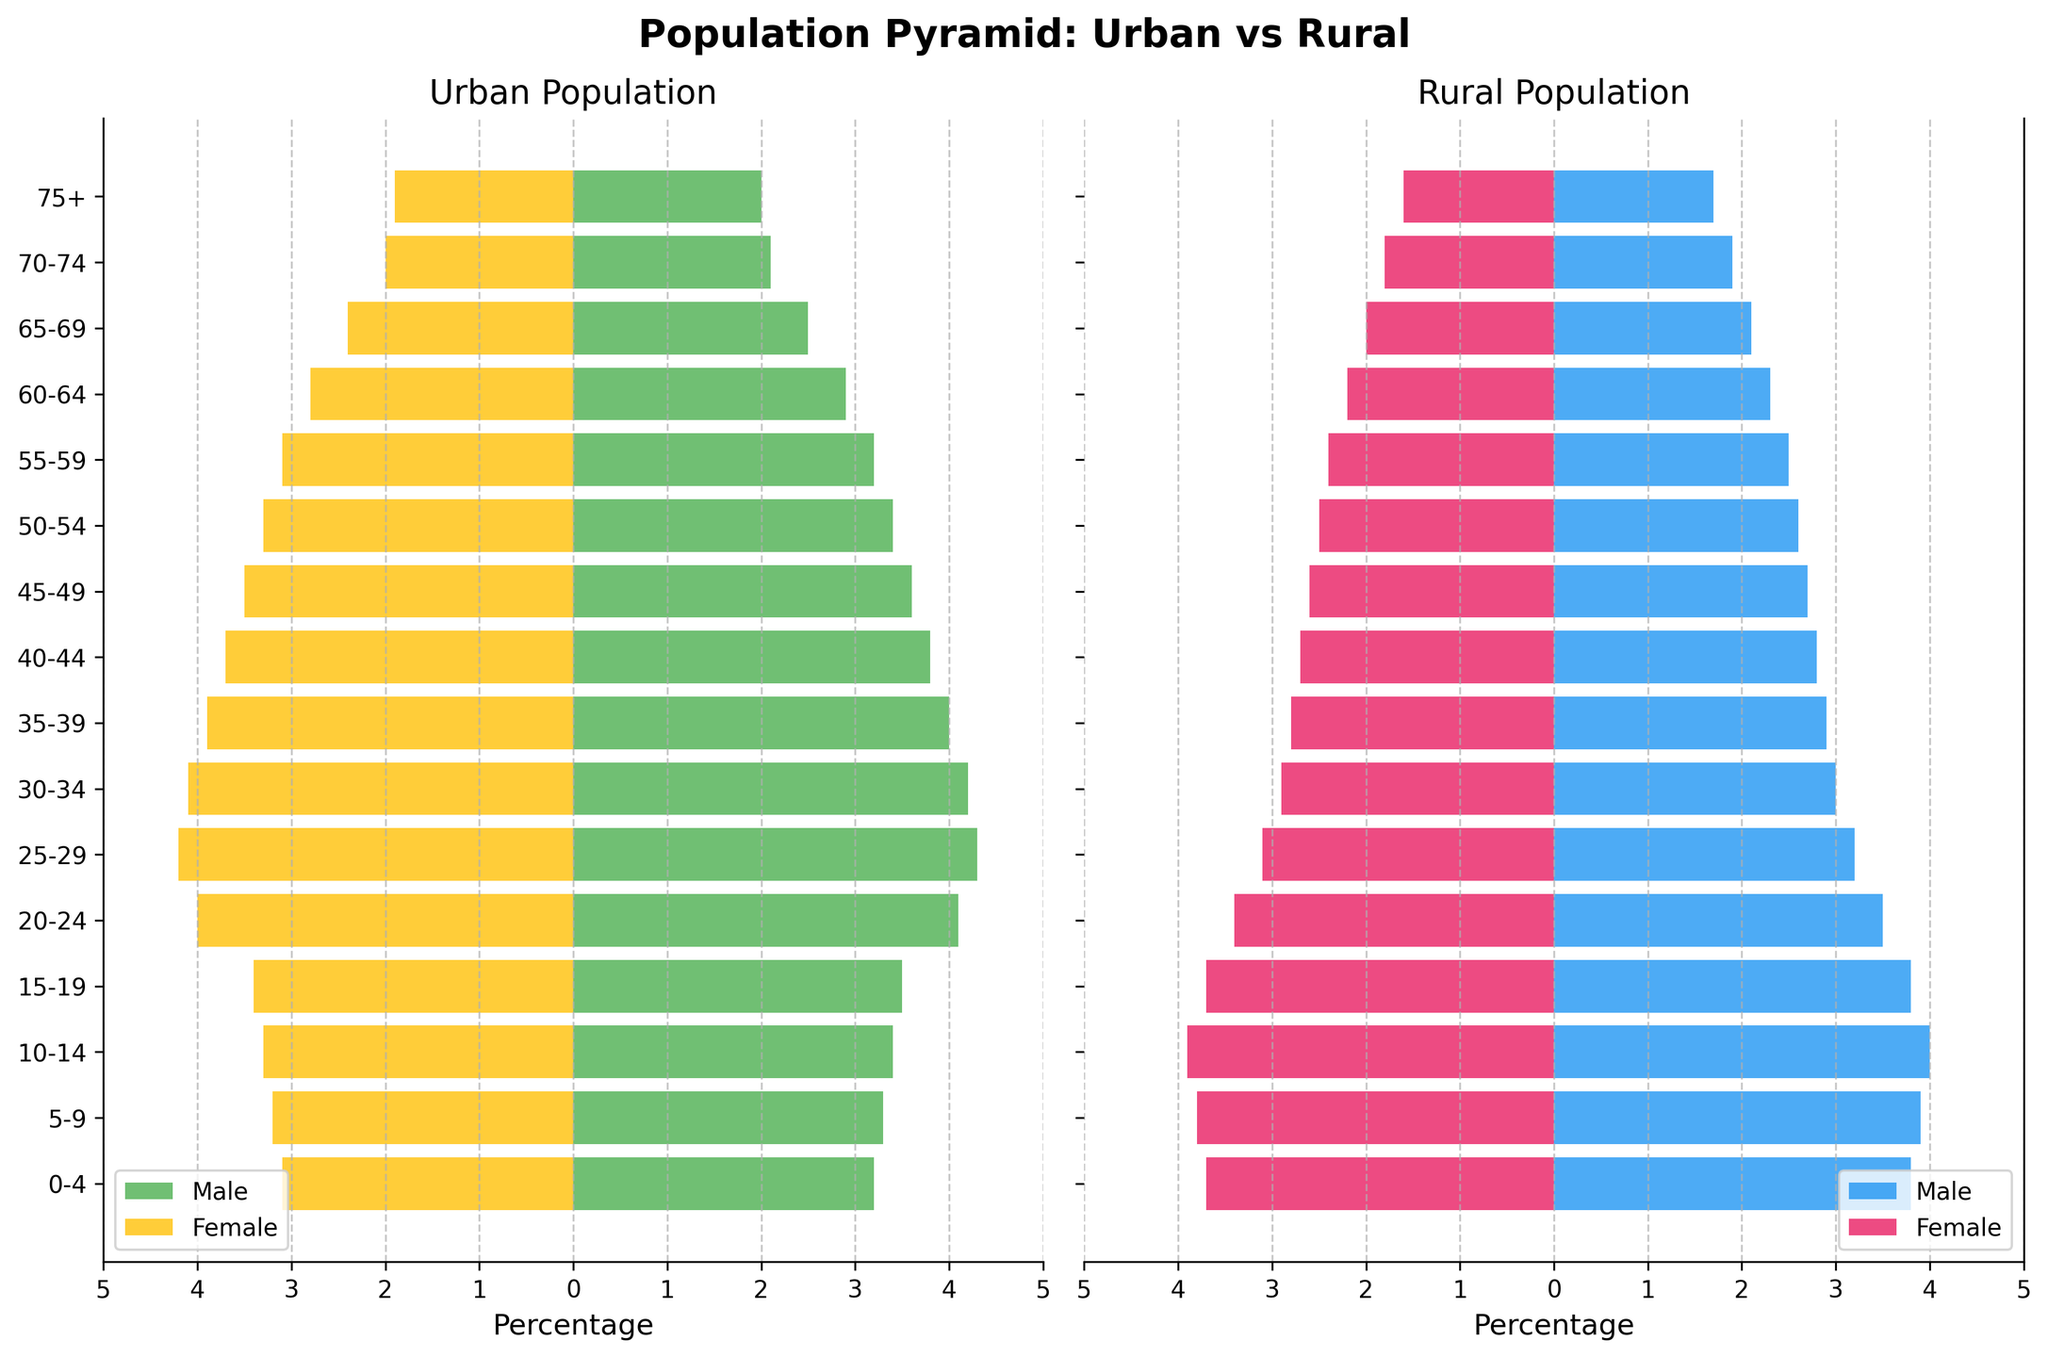What is the title of the figure? The title is usually found at the top of the figure, typically in bold. In this case, it says "Population Pyramid: Urban vs Rural".
Answer: Population Pyramid: Urban vs Rural Which age group has the largest urban female population? To find the largest urban female population, look at the bars on the left representing urban females and note the longest. The 25-29 age group has the longest bar.
Answer: 25-29 Between which age groups is the difference between urban male and female population the smallest? Compare the lengths of corresponding urban male and female bars. The smallest difference should be where the male and female bars are closest in length. This occurs in the 0-4 age group.
Answer: 0-4 What is the percentage of rural males in the 30-34 age group? Find the bar representing rural males in the 30-34 age group on the right side of the figure and note its length. The length corresponds to 3.0%.
Answer: 3.0% Which group between urban and rural shows a higher percentage of the population in the 75+ age group? Compare the lengths of the bars representing the 75+ age group for both urban and rural populations. The urban population bars (male and female) are longer than the rural ones.
Answer: Urban What age group sees the highest percentage of urban males? To find the peak urban male percentage, look for the longest urban male bar. The longest bar is in the 25-29 age group.
Answer: 25-29 What is the overall trend observed in the rural population as age increases? Look at the height of the bars for rural males and females from the 0-4 age group to the 75+ age group and note the overall pattern. The bars generally decrease in length as age increases.
Answer: Decreasing How does the percentage of urban females in the 20-24 age group compare to rural females in the same age group? Compare the lengths of the urban female and rural female bars in the 20-24 age group. The urban female percentage is notably higher than the rural female percentage.
Answer: Urban females have a higher percentage By how much does the percentage of urban females in the 65-69 age group differ from rural females in the same age group? Note the lengths of the bars representing these groups and calculate the difference. Urban females have 2.4%, and rural females have 2.0%, so the difference is 2.4% - 2.0% = 0.4%.
Answer: 0.4% What observation can you make from the distribution of the 15-19 age group across urban and rural populations? Compare the heights of the bars for the 15-19 age group in both urban and rural sections. The urban male and female bars are equal, whereas the rural male and female bars are also equal but larger than their urban counterparts.
Answer: Rural population has a higher percentage 